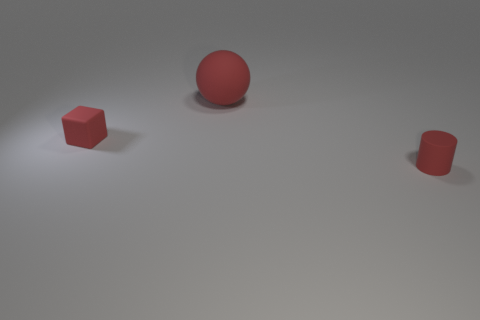Are there any other things that have the same size as the red sphere?
Your answer should be very brief. No. Are the big ball and the small cylinder made of the same material?
Your response must be concise. Yes. The red matte thing that is behind the tiny cylinder and in front of the large red matte sphere has what shape?
Your answer should be compact. Cube. What is the shape of the tiny object that is made of the same material as the cylinder?
Keep it short and to the point. Cube. Are any gray rubber cylinders visible?
Offer a terse response. No. There is a tiny red thing to the left of the tiny cylinder; is there a small object in front of it?
Give a very brief answer. Yes. Are there more red things than tiny purple rubber objects?
Keep it short and to the point. Yes. There is a rubber object that is both behind the small red rubber cylinder and in front of the large ball; what is its color?
Offer a very short reply. Red. How many other things are the same material as the red ball?
Offer a terse response. 2. Is the number of yellow matte things less than the number of small matte cubes?
Offer a terse response. Yes. 